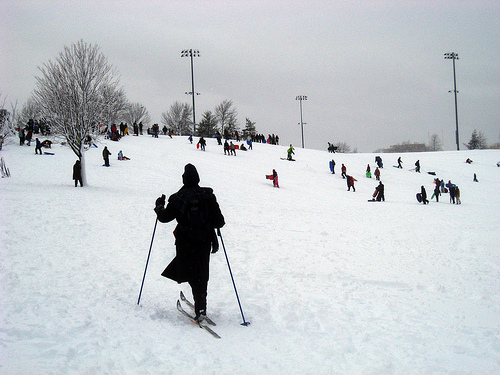Please provide a short description for this region: [0.37, 0.23, 0.41, 0.39]. A sturdy metal light post standing out against the snowy backdrop. 